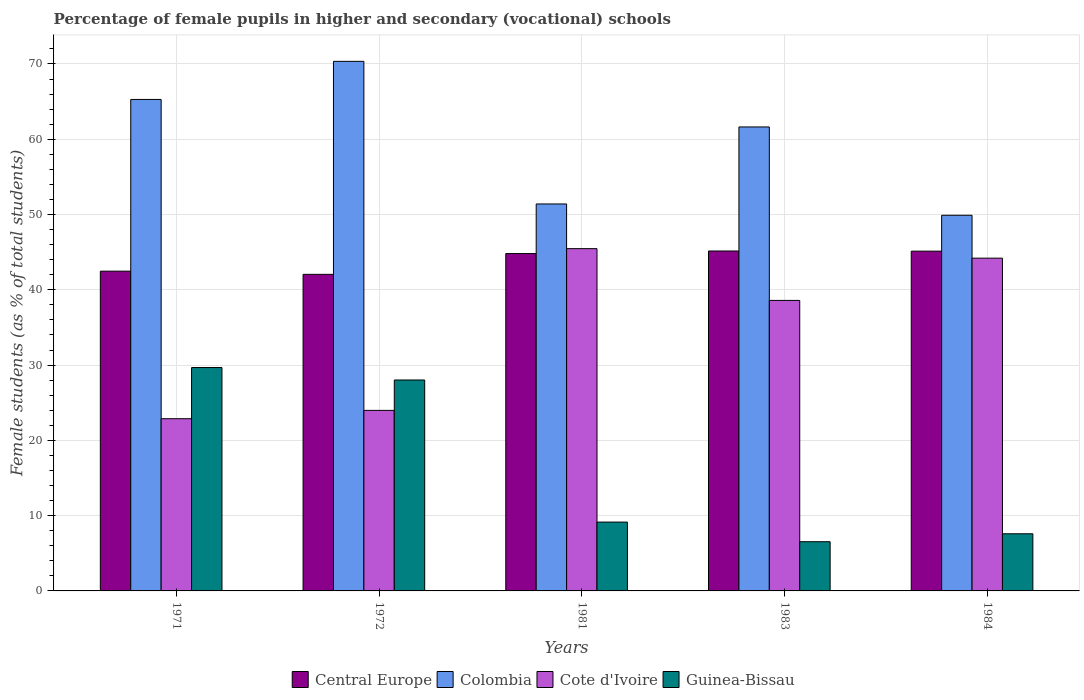How many groups of bars are there?
Your response must be concise. 5. How many bars are there on the 5th tick from the left?
Offer a very short reply. 4. How many bars are there on the 3rd tick from the right?
Offer a terse response. 4. In how many cases, is the number of bars for a given year not equal to the number of legend labels?
Provide a short and direct response. 0. What is the percentage of female pupils in higher and secondary schools in Guinea-Bissau in 1983?
Ensure brevity in your answer.  6.54. Across all years, what is the maximum percentage of female pupils in higher and secondary schools in Guinea-Bissau?
Give a very brief answer. 29.67. Across all years, what is the minimum percentage of female pupils in higher and secondary schools in Cote d'Ivoire?
Keep it short and to the point. 22.88. In which year was the percentage of female pupils in higher and secondary schools in Guinea-Bissau maximum?
Offer a very short reply. 1971. What is the total percentage of female pupils in higher and secondary schools in Central Europe in the graph?
Give a very brief answer. 219.63. What is the difference between the percentage of female pupils in higher and secondary schools in Colombia in 1971 and that in 1984?
Make the answer very short. 15.38. What is the difference between the percentage of female pupils in higher and secondary schools in Central Europe in 1983 and the percentage of female pupils in higher and secondary schools in Cote d'Ivoire in 1984?
Your answer should be very brief. 0.95. What is the average percentage of female pupils in higher and secondary schools in Cote d'Ivoire per year?
Your answer should be very brief. 35.02. In the year 1981, what is the difference between the percentage of female pupils in higher and secondary schools in Cote d'Ivoire and percentage of female pupils in higher and secondary schools in Central Europe?
Make the answer very short. 0.65. What is the ratio of the percentage of female pupils in higher and secondary schools in Guinea-Bissau in 1971 to that in 1972?
Offer a terse response. 1.06. Is the percentage of female pupils in higher and secondary schools in Central Europe in 1971 less than that in 1984?
Provide a short and direct response. Yes. What is the difference between the highest and the second highest percentage of female pupils in higher and secondary schools in Central Europe?
Your answer should be very brief. 0.02. What is the difference between the highest and the lowest percentage of female pupils in higher and secondary schools in Guinea-Bissau?
Provide a succinct answer. 23.14. Is it the case that in every year, the sum of the percentage of female pupils in higher and secondary schools in Cote d'Ivoire and percentage of female pupils in higher and secondary schools in Colombia is greater than the sum of percentage of female pupils in higher and secondary schools in Guinea-Bissau and percentage of female pupils in higher and secondary schools in Central Europe?
Your answer should be very brief. Yes. What does the 2nd bar from the left in 1972 represents?
Give a very brief answer. Colombia. What does the 2nd bar from the right in 1981 represents?
Your answer should be compact. Cote d'Ivoire. Is it the case that in every year, the sum of the percentage of female pupils in higher and secondary schools in Central Europe and percentage of female pupils in higher and secondary schools in Cote d'Ivoire is greater than the percentage of female pupils in higher and secondary schools in Colombia?
Your answer should be compact. No. Does the graph contain any zero values?
Offer a very short reply. No. Where does the legend appear in the graph?
Offer a terse response. Bottom center. How are the legend labels stacked?
Offer a very short reply. Horizontal. What is the title of the graph?
Provide a short and direct response. Percentage of female pupils in higher and secondary (vocational) schools. What is the label or title of the X-axis?
Offer a terse response. Years. What is the label or title of the Y-axis?
Keep it short and to the point. Female students (as % of total students). What is the Female students (as % of total students) in Central Europe in 1971?
Provide a succinct answer. 42.48. What is the Female students (as % of total students) of Colombia in 1971?
Keep it short and to the point. 65.28. What is the Female students (as % of total students) in Cote d'Ivoire in 1971?
Ensure brevity in your answer.  22.88. What is the Female students (as % of total students) of Guinea-Bissau in 1971?
Provide a short and direct response. 29.67. What is the Female students (as % of total students) of Central Europe in 1972?
Provide a short and direct response. 42.05. What is the Female students (as % of total students) of Colombia in 1972?
Offer a terse response. 70.34. What is the Female students (as % of total students) in Cote d'Ivoire in 1972?
Offer a very short reply. 23.98. What is the Female students (as % of total students) of Guinea-Bissau in 1972?
Give a very brief answer. 28.02. What is the Female students (as % of total students) of Central Europe in 1981?
Give a very brief answer. 44.81. What is the Female students (as % of total students) of Colombia in 1981?
Your answer should be compact. 51.4. What is the Female students (as % of total students) of Cote d'Ivoire in 1981?
Ensure brevity in your answer.  45.47. What is the Female students (as % of total students) in Guinea-Bissau in 1981?
Make the answer very short. 9.14. What is the Female students (as % of total students) in Central Europe in 1983?
Give a very brief answer. 45.15. What is the Female students (as % of total students) of Colombia in 1983?
Your answer should be very brief. 61.63. What is the Female students (as % of total students) in Cote d'Ivoire in 1983?
Make the answer very short. 38.59. What is the Female students (as % of total students) in Guinea-Bissau in 1983?
Provide a succinct answer. 6.54. What is the Female students (as % of total students) in Central Europe in 1984?
Offer a terse response. 45.13. What is the Female students (as % of total students) in Colombia in 1984?
Your response must be concise. 49.9. What is the Female students (as % of total students) in Cote d'Ivoire in 1984?
Offer a very short reply. 44.2. What is the Female students (as % of total students) of Guinea-Bissau in 1984?
Your answer should be compact. 7.59. Across all years, what is the maximum Female students (as % of total students) in Central Europe?
Your answer should be compact. 45.15. Across all years, what is the maximum Female students (as % of total students) of Colombia?
Your answer should be very brief. 70.34. Across all years, what is the maximum Female students (as % of total students) of Cote d'Ivoire?
Make the answer very short. 45.47. Across all years, what is the maximum Female students (as % of total students) of Guinea-Bissau?
Ensure brevity in your answer.  29.67. Across all years, what is the minimum Female students (as % of total students) of Central Europe?
Offer a very short reply. 42.05. Across all years, what is the minimum Female students (as % of total students) in Colombia?
Ensure brevity in your answer.  49.9. Across all years, what is the minimum Female students (as % of total students) of Cote d'Ivoire?
Ensure brevity in your answer.  22.88. Across all years, what is the minimum Female students (as % of total students) of Guinea-Bissau?
Your answer should be very brief. 6.54. What is the total Female students (as % of total students) in Central Europe in the graph?
Ensure brevity in your answer.  219.63. What is the total Female students (as % of total students) in Colombia in the graph?
Your answer should be very brief. 298.56. What is the total Female students (as % of total students) in Cote d'Ivoire in the graph?
Ensure brevity in your answer.  175.11. What is the total Female students (as % of total students) in Guinea-Bissau in the graph?
Your response must be concise. 80.96. What is the difference between the Female students (as % of total students) in Central Europe in 1971 and that in 1972?
Provide a short and direct response. 0.43. What is the difference between the Female students (as % of total students) of Colombia in 1971 and that in 1972?
Offer a terse response. -5.06. What is the difference between the Female students (as % of total students) in Cote d'Ivoire in 1971 and that in 1972?
Make the answer very short. -1.11. What is the difference between the Female students (as % of total students) in Guinea-Bissau in 1971 and that in 1972?
Keep it short and to the point. 1.65. What is the difference between the Female students (as % of total students) in Central Europe in 1971 and that in 1981?
Provide a succinct answer. -2.34. What is the difference between the Female students (as % of total students) of Colombia in 1971 and that in 1981?
Offer a very short reply. 13.88. What is the difference between the Female students (as % of total students) of Cote d'Ivoire in 1971 and that in 1981?
Offer a terse response. -22.59. What is the difference between the Female students (as % of total students) of Guinea-Bissau in 1971 and that in 1981?
Offer a very short reply. 20.53. What is the difference between the Female students (as % of total students) of Central Europe in 1971 and that in 1983?
Provide a succinct answer. -2.68. What is the difference between the Female students (as % of total students) in Colombia in 1971 and that in 1983?
Make the answer very short. 3.65. What is the difference between the Female students (as % of total students) of Cote d'Ivoire in 1971 and that in 1983?
Provide a short and direct response. -15.71. What is the difference between the Female students (as % of total students) in Guinea-Bissau in 1971 and that in 1983?
Make the answer very short. 23.14. What is the difference between the Female students (as % of total students) of Central Europe in 1971 and that in 1984?
Provide a succinct answer. -2.66. What is the difference between the Female students (as % of total students) of Colombia in 1971 and that in 1984?
Provide a succinct answer. 15.38. What is the difference between the Female students (as % of total students) in Cote d'Ivoire in 1971 and that in 1984?
Make the answer very short. -21.32. What is the difference between the Female students (as % of total students) of Guinea-Bissau in 1971 and that in 1984?
Make the answer very short. 22.08. What is the difference between the Female students (as % of total students) in Central Europe in 1972 and that in 1981?
Keep it short and to the point. -2.76. What is the difference between the Female students (as % of total students) in Colombia in 1972 and that in 1981?
Provide a short and direct response. 18.94. What is the difference between the Female students (as % of total students) of Cote d'Ivoire in 1972 and that in 1981?
Ensure brevity in your answer.  -21.48. What is the difference between the Female students (as % of total students) in Guinea-Bissau in 1972 and that in 1981?
Ensure brevity in your answer.  18.88. What is the difference between the Female students (as % of total students) of Central Europe in 1972 and that in 1983?
Offer a terse response. -3.1. What is the difference between the Female students (as % of total students) in Colombia in 1972 and that in 1983?
Ensure brevity in your answer.  8.71. What is the difference between the Female students (as % of total students) of Cote d'Ivoire in 1972 and that in 1983?
Your answer should be compact. -14.61. What is the difference between the Female students (as % of total students) in Guinea-Bissau in 1972 and that in 1983?
Keep it short and to the point. 21.48. What is the difference between the Female students (as % of total students) of Central Europe in 1972 and that in 1984?
Offer a very short reply. -3.08. What is the difference between the Female students (as % of total students) in Colombia in 1972 and that in 1984?
Ensure brevity in your answer.  20.44. What is the difference between the Female students (as % of total students) in Cote d'Ivoire in 1972 and that in 1984?
Give a very brief answer. -20.22. What is the difference between the Female students (as % of total students) of Guinea-Bissau in 1972 and that in 1984?
Your answer should be very brief. 20.43. What is the difference between the Female students (as % of total students) in Central Europe in 1981 and that in 1983?
Offer a very short reply. -0.34. What is the difference between the Female students (as % of total students) in Colombia in 1981 and that in 1983?
Provide a short and direct response. -10.23. What is the difference between the Female students (as % of total students) in Cote d'Ivoire in 1981 and that in 1983?
Make the answer very short. 6.88. What is the difference between the Female students (as % of total students) of Guinea-Bissau in 1981 and that in 1983?
Offer a terse response. 2.61. What is the difference between the Female students (as % of total students) of Central Europe in 1981 and that in 1984?
Ensure brevity in your answer.  -0.32. What is the difference between the Female students (as % of total students) of Colombia in 1981 and that in 1984?
Your answer should be compact. 1.5. What is the difference between the Female students (as % of total students) in Cote d'Ivoire in 1981 and that in 1984?
Your answer should be very brief. 1.26. What is the difference between the Female students (as % of total students) of Guinea-Bissau in 1981 and that in 1984?
Your answer should be compact. 1.55. What is the difference between the Female students (as % of total students) of Central Europe in 1983 and that in 1984?
Your answer should be very brief. 0.02. What is the difference between the Female students (as % of total students) in Colombia in 1983 and that in 1984?
Your response must be concise. 11.73. What is the difference between the Female students (as % of total students) of Cote d'Ivoire in 1983 and that in 1984?
Your answer should be compact. -5.61. What is the difference between the Female students (as % of total students) in Guinea-Bissau in 1983 and that in 1984?
Ensure brevity in your answer.  -1.05. What is the difference between the Female students (as % of total students) of Central Europe in 1971 and the Female students (as % of total students) of Colombia in 1972?
Keep it short and to the point. -27.87. What is the difference between the Female students (as % of total students) of Central Europe in 1971 and the Female students (as % of total students) of Cote d'Ivoire in 1972?
Make the answer very short. 18.49. What is the difference between the Female students (as % of total students) in Central Europe in 1971 and the Female students (as % of total students) in Guinea-Bissau in 1972?
Give a very brief answer. 14.46. What is the difference between the Female students (as % of total students) of Colombia in 1971 and the Female students (as % of total students) of Cote d'Ivoire in 1972?
Offer a terse response. 41.3. What is the difference between the Female students (as % of total students) in Colombia in 1971 and the Female students (as % of total students) in Guinea-Bissau in 1972?
Your response must be concise. 37.26. What is the difference between the Female students (as % of total students) of Cote d'Ivoire in 1971 and the Female students (as % of total students) of Guinea-Bissau in 1972?
Your response must be concise. -5.14. What is the difference between the Female students (as % of total students) of Central Europe in 1971 and the Female students (as % of total students) of Colombia in 1981?
Provide a short and direct response. -8.92. What is the difference between the Female students (as % of total students) in Central Europe in 1971 and the Female students (as % of total students) in Cote d'Ivoire in 1981?
Provide a succinct answer. -2.99. What is the difference between the Female students (as % of total students) in Central Europe in 1971 and the Female students (as % of total students) in Guinea-Bissau in 1981?
Give a very brief answer. 33.33. What is the difference between the Female students (as % of total students) of Colombia in 1971 and the Female students (as % of total students) of Cote d'Ivoire in 1981?
Your answer should be very brief. 19.82. What is the difference between the Female students (as % of total students) of Colombia in 1971 and the Female students (as % of total students) of Guinea-Bissau in 1981?
Keep it short and to the point. 56.14. What is the difference between the Female students (as % of total students) in Cote d'Ivoire in 1971 and the Female students (as % of total students) in Guinea-Bissau in 1981?
Ensure brevity in your answer.  13.73. What is the difference between the Female students (as % of total students) of Central Europe in 1971 and the Female students (as % of total students) of Colombia in 1983?
Your answer should be compact. -19.15. What is the difference between the Female students (as % of total students) in Central Europe in 1971 and the Female students (as % of total students) in Cote d'Ivoire in 1983?
Your answer should be very brief. 3.89. What is the difference between the Female students (as % of total students) of Central Europe in 1971 and the Female students (as % of total students) of Guinea-Bissau in 1983?
Provide a short and direct response. 35.94. What is the difference between the Female students (as % of total students) in Colombia in 1971 and the Female students (as % of total students) in Cote d'Ivoire in 1983?
Keep it short and to the point. 26.69. What is the difference between the Female students (as % of total students) in Colombia in 1971 and the Female students (as % of total students) in Guinea-Bissau in 1983?
Provide a short and direct response. 58.75. What is the difference between the Female students (as % of total students) in Cote d'Ivoire in 1971 and the Female students (as % of total students) in Guinea-Bissau in 1983?
Your response must be concise. 16.34. What is the difference between the Female students (as % of total students) in Central Europe in 1971 and the Female students (as % of total students) in Colombia in 1984?
Offer a very short reply. -7.42. What is the difference between the Female students (as % of total students) in Central Europe in 1971 and the Female students (as % of total students) in Cote d'Ivoire in 1984?
Offer a very short reply. -1.72. What is the difference between the Female students (as % of total students) of Central Europe in 1971 and the Female students (as % of total students) of Guinea-Bissau in 1984?
Ensure brevity in your answer.  34.89. What is the difference between the Female students (as % of total students) of Colombia in 1971 and the Female students (as % of total students) of Cote d'Ivoire in 1984?
Provide a succinct answer. 21.08. What is the difference between the Female students (as % of total students) in Colombia in 1971 and the Female students (as % of total students) in Guinea-Bissau in 1984?
Your response must be concise. 57.69. What is the difference between the Female students (as % of total students) of Cote d'Ivoire in 1971 and the Female students (as % of total students) of Guinea-Bissau in 1984?
Your answer should be very brief. 15.29. What is the difference between the Female students (as % of total students) in Central Europe in 1972 and the Female students (as % of total students) in Colombia in 1981?
Provide a succinct answer. -9.35. What is the difference between the Female students (as % of total students) of Central Europe in 1972 and the Female students (as % of total students) of Cote d'Ivoire in 1981?
Your answer should be very brief. -3.42. What is the difference between the Female students (as % of total students) of Central Europe in 1972 and the Female students (as % of total students) of Guinea-Bissau in 1981?
Offer a very short reply. 32.91. What is the difference between the Female students (as % of total students) of Colombia in 1972 and the Female students (as % of total students) of Cote d'Ivoire in 1981?
Give a very brief answer. 24.88. What is the difference between the Female students (as % of total students) in Colombia in 1972 and the Female students (as % of total students) in Guinea-Bissau in 1981?
Ensure brevity in your answer.  61.2. What is the difference between the Female students (as % of total students) in Cote d'Ivoire in 1972 and the Female students (as % of total students) in Guinea-Bissau in 1981?
Keep it short and to the point. 14.84. What is the difference between the Female students (as % of total students) in Central Europe in 1972 and the Female students (as % of total students) in Colombia in 1983?
Your response must be concise. -19.58. What is the difference between the Female students (as % of total students) of Central Europe in 1972 and the Female students (as % of total students) of Cote d'Ivoire in 1983?
Ensure brevity in your answer.  3.46. What is the difference between the Female students (as % of total students) in Central Europe in 1972 and the Female students (as % of total students) in Guinea-Bissau in 1983?
Offer a terse response. 35.51. What is the difference between the Female students (as % of total students) in Colombia in 1972 and the Female students (as % of total students) in Cote d'Ivoire in 1983?
Keep it short and to the point. 31.75. What is the difference between the Female students (as % of total students) in Colombia in 1972 and the Female students (as % of total students) in Guinea-Bissau in 1983?
Offer a very short reply. 63.81. What is the difference between the Female students (as % of total students) of Cote d'Ivoire in 1972 and the Female students (as % of total students) of Guinea-Bissau in 1983?
Your answer should be compact. 17.45. What is the difference between the Female students (as % of total students) in Central Europe in 1972 and the Female students (as % of total students) in Colombia in 1984?
Provide a short and direct response. -7.85. What is the difference between the Female students (as % of total students) in Central Europe in 1972 and the Female students (as % of total students) in Cote d'Ivoire in 1984?
Offer a terse response. -2.15. What is the difference between the Female students (as % of total students) in Central Europe in 1972 and the Female students (as % of total students) in Guinea-Bissau in 1984?
Your response must be concise. 34.46. What is the difference between the Female students (as % of total students) in Colombia in 1972 and the Female students (as % of total students) in Cote d'Ivoire in 1984?
Your answer should be very brief. 26.14. What is the difference between the Female students (as % of total students) in Colombia in 1972 and the Female students (as % of total students) in Guinea-Bissau in 1984?
Provide a short and direct response. 62.75. What is the difference between the Female students (as % of total students) in Cote d'Ivoire in 1972 and the Female students (as % of total students) in Guinea-Bissau in 1984?
Offer a very short reply. 16.39. What is the difference between the Female students (as % of total students) of Central Europe in 1981 and the Female students (as % of total students) of Colombia in 1983?
Make the answer very short. -16.82. What is the difference between the Female students (as % of total students) of Central Europe in 1981 and the Female students (as % of total students) of Cote d'Ivoire in 1983?
Your response must be concise. 6.22. What is the difference between the Female students (as % of total students) of Central Europe in 1981 and the Female students (as % of total students) of Guinea-Bissau in 1983?
Ensure brevity in your answer.  38.28. What is the difference between the Female students (as % of total students) in Colombia in 1981 and the Female students (as % of total students) in Cote d'Ivoire in 1983?
Your answer should be compact. 12.81. What is the difference between the Female students (as % of total students) in Colombia in 1981 and the Female students (as % of total students) in Guinea-Bissau in 1983?
Make the answer very short. 44.87. What is the difference between the Female students (as % of total students) of Cote d'Ivoire in 1981 and the Female students (as % of total students) of Guinea-Bissau in 1983?
Provide a succinct answer. 38.93. What is the difference between the Female students (as % of total students) in Central Europe in 1981 and the Female students (as % of total students) in Colombia in 1984?
Offer a very short reply. -5.09. What is the difference between the Female students (as % of total students) in Central Europe in 1981 and the Female students (as % of total students) in Cote d'Ivoire in 1984?
Ensure brevity in your answer.  0.61. What is the difference between the Female students (as % of total students) of Central Europe in 1981 and the Female students (as % of total students) of Guinea-Bissau in 1984?
Keep it short and to the point. 37.22. What is the difference between the Female students (as % of total students) in Colombia in 1981 and the Female students (as % of total students) in Cote d'Ivoire in 1984?
Provide a succinct answer. 7.2. What is the difference between the Female students (as % of total students) in Colombia in 1981 and the Female students (as % of total students) in Guinea-Bissau in 1984?
Offer a very short reply. 43.81. What is the difference between the Female students (as % of total students) in Cote d'Ivoire in 1981 and the Female students (as % of total students) in Guinea-Bissau in 1984?
Your answer should be compact. 37.87. What is the difference between the Female students (as % of total students) in Central Europe in 1983 and the Female students (as % of total students) in Colombia in 1984?
Offer a very short reply. -4.75. What is the difference between the Female students (as % of total students) in Central Europe in 1983 and the Female students (as % of total students) in Cote d'Ivoire in 1984?
Your answer should be compact. 0.95. What is the difference between the Female students (as % of total students) of Central Europe in 1983 and the Female students (as % of total students) of Guinea-Bissau in 1984?
Your answer should be very brief. 37.56. What is the difference between the Female students (as % of total students) of Colombia in 1983 and the Female students (as % of total students) of Cote d'Ivoire in 1984?
Keep it short and to the point. 17.43. What is the difference between the Female students (as % of total students) of Colombia in 1983 and the Female students (as % of total students) of Guinea-Bissau in 1984?
Provide a succinct answer. 54.04. What is the difference between the Female students (as % of total students) in Cote d'Ivoire in 1983 and the Female students (as % of total students) in Guinea-Bissau in 1984?
Offer a very short reply. 31. What is the average Female students (as % of total students) of Central Europe per year?
Make the answer very short. 43.93. What is the average Female students (as % of total students) in Colombia per year?
Provide a succinct answer. 59.71. What is the average Female students (as % of total students) in Cote d'Ivoire per year?
Make the answer very short. 35.02. What is the average Female students (as % of total students) in Guinea-Bissau per year?
Keep it short and to the point. 16.19. In the year 1971, what is the difference between the Female students (as % of total students) of Central Europe and Female students (as % of total students) of Colombia?
Provide a short and direct response. -22.81. In the year 1971, what is the difference between the Female students (as % of total students) in Central Europe and Female students (as % of total students) in Cote d'Ivoire?
Ensure brevity in your answer.  19.6. In the year 1971, what is the difference between the Female students (as % of total students) of Central Europe and Female students (as % of total students) of Guinea-Bissau?
Keep it short and to the point. 12.8. In the year 1971, what is the difference between the Female students (as % of total students) of Colombia and Female students (as % of total students) of Cote d'Ivoire?
Give a very brief answer. 42.41. In the year 1971, what is the difference between the Female students (as % of total students) of Colombia and Female students (as % of total students) of Guinea-Bissau?
Give a very brief answer. 35.61. In the year 1971, what is the difference between the Female students (as % of total students) of Cote d'Ivoire and Female students (as % of total students) of Guinea-Bissau?
Provide a succinct answer. -6.8. In the year 1972, what is the difference between the Female students (as % of total students) in Central Europe and Female students (as % of total students) in Colombia?
Your answer should be very brief. -28.29. In the year 1972, what is the difference between the Female students (as % of total students) of Central Europe and Female students (as % of total students) of Cote d'Ivoire?
Give a very brief answer. 18.07. In the year 1972, what is the difference between the Female students (as % of total students) of Central Europe and Female students (as % of total students) of Guinea-Bissau?
Your answer should be compact. 14.03. In the year 1972, what is the difference between the Female students (as % of total students) of Colombia and Female students (as % of total students) of Cote d'Ivoire?
Your answer should be compact. 46.36. In the year 1972, what is the difference between the Female students (as % of total students) in Colombia and Female students (as % of total students) in Guinea-Bissau?
Keep it short and to the point. 42.33. In the year 1972, what is the difference between the Female students (as % of total students) in Cote d'Ivoire and Female students (as % of total students) in Guinea-Bissau?
Give a very brief answer. -4.04. In the year 1981, what is the difference between the Female students (as % of total students) of Central Europe and Female students (as % of total students) of Colombia?
Offer a terse response. -6.59. In the year 1981, what is the difference between the Female students (as % of total students) of Central Europe and Female students (as % of total students) of Cote d'Ivoire?
Ensure brevity in your answer.  -0.65. In the year 1981, what is the difference between the Female students (as % of total students) of Central Europe and Female students (as % of total students) of Guinea-Bissau?
Keep it short and to the point. 35.67. In the year 1981, what is the difference between the Female students (as % of total students) in Colombia and Female students (as % of total students) in Cote d'Ivoire?
Provide a succinct answer. 5.94. In the year 1981, what is the difference between the Female students (as % of total students) in Colombia and Female students (as % of total students) in Guinea-Bissau?
Make the answer very short. 42.26. In the year 1981, what is the difference between the Female students (as % of total students) in Cote d'Ivoire and Female students (as % of total students) in Guinea-Bissau?
Give a very brief answer. 36.32. In the year 1983, what is the difference between the Female students (as % of total students) of Central Europe and Female students (as % of total students) of Colombia?
Provide a short and direct response. -16.48. In the year 1983, what is the difference between the Female students (as % of total students) of Central Europe and Female students (as % of total students) of Cote d'Ivoire?
Your response must be concise. 6.56. In the year 1983, what is the difference between the Female students (as % of total students) in Central Europe and Female students (as % of total students) in Guinea-Bissau?
Keep it short and to the point. 38.62. In the year 1983, what is the difference between the Female students (as % of total students) of Colombia and Female students (as % of total students) of Cote d'Ivoire?
Make the answer very short. 23.04. In the year 1983, what is the difference between the Female students (as % of total students) of Colombia and Female students (as % of total students) of Guinea-Bissau?
Offer a very short reply. 55.1. In the year 1983, what is the difference between the Female students (as % of total students) in Cote d'Ivoire and Female students (as % of total students) in Guinea-Bissau?
Provide a short and direct response. 32.05. In the year 1984, what is the difference between the Female students (as % of total students) in Central Europe and Female students (as % of total students) in Colombia?
Give a very brief answer. -4.77. In the year 1984, what is the difference between the Female students (as % of total students) in Central Europe and Female students (as % of total students) in Cote d'Ivoire?
Keep it short and to the point. 0.93. In the year 1984, what is the difference between the Female students (as % of total students) of Central Europe and Female students (as % of total students) of Guinea-Bissau?
Offer a terse response. 37.54. In the year 1984, what is the difference between the Female students (as % of total students) in Colombia and Female students (as % of total students) in Cote d'Ivoire?
Keep it short and to the point. 5.7. In the year 1984, what is the difference between the Female students (as % of total students) of Colombia and Female students (as % of total students) of Guinea-Bissau?
Offer a very short reply. 42.31. In the year 1984, what is the difference between the Female students (as % of total students) in Cote d'Ivoire and Female students (as % of total students) in Guinea-Bissau?
Offer a terse response. 36.61. What is the ratio of the Female students (as % of total students) in Central Europe in 1971 to that in 1972?
Your response must be concise. 1.01. What is the ratio of the Female students (as % of total students) in Colombia in 1971 to that in 1972?
Make the answer very short. 0.93. What is the ratio of the Female students (as % of total students) of Cote d'Ivoire in 1971 to that in 1972?
Make the answer very short. 0.95. What is the ratio of the Female students (as % of total students) in Guinea-Bissau in 1971 to that in 1972?
Offer a terse response. 1.06. What is the ratio of the Female students (as % of total students) in Central Europe in 1971 to that in 1981?
Provide a short and direct response. 0.95. What is the ratio of the Female students (as % of total students) of Colombia in 1971 to that in 1981?
Give a very brief answer. 1.27. What is the ratio of the Female students (as % of total students) in Cote d'Ivoire in 1971 to that in 1981?
Your answer should be compact. 0.5. What is the ratio of the Female students (as % of total students) of Guinea-Bissau in 1971 to that in 1981?
Your response must be concise. 3.25. What is the ratio of the Female students (as % of total students) of Central Europe in 1971 to that in 1983?
Provide a succinct answer. 0.94. What is the ratio of the Female students (as % of total students) in Colombia in 1971 to that in 1983?
Your response must be concise. 1.06. What is the ratio of the Female students (as % of total students) of Cote d'Ivoire in 1971 to that in 1983?
Keep it short and to the point. 0.59. What is the ratio of the Female students (as % of total students) of Guinea-Bissau in 1971 to that in 1983?
Keep it short and to the point. 4.54. What is the ratio of the Female students (as % of total students) in Central Europe in 1971 to that in 1984?
Offer a terse response. 0.94. What is the ratio of the Female students (as % of total students) in Colombia in 1971 to that in 1984?
Offer a terse response. 1.31. What is the ratio of the Female students (as % of total students) in Cote d'Ivoire in 1971 to that in 1984?
Your response must be concise. 0.52. What is the ratio of the Female students (as % of total students) of Guinea-Bissau in 1971 to that in 1984?
Provide a succinct answer. 3.91. What is the ratio of the Female students (as % of total students) of Central Europe in 1972 to that in 1981?
Ensure brevity in your answer.  0.94. What is the ratio of the Female students (as % of total students) in Colombia in 1972 to that in 1981?
Give a very brief answer. 1.37. What is the ratio of the Female students (as % of total students) in Cote d'Ivoire in 1972 to that in 1981?
Provide a succinct answer. 0.53. What is the ratio of the Female students (as % of total students) in Guinea-Bissau in 1972 to that in 1981?
Give a very brief answer. 3.06. What is the ratio of the Female students (as % of total students) of Central Europe in 1972 to that in 1983?
Your response must be concise. 0.93. What is the ratio of the Female students (as % of total students) of Colombia in 1972 to that in 1983?
Your answer should be compact. 1.14. What is the ratio of the Female students (as % of total students) of Cote d'Ivoire in 1972 to that in 1983?
Give a very brief answer. 0.62. What is the ratio of the Female students (as % of total students) of Guinea-Bissau in 1972 to that in 1983?
Make the answer very short. 4.29. What is the ratio of the Female students (as % of total students) of Central Europe in 1972 to that in 1984?
Provide a succinct answer. 0.93. What is the ratio of the Female students (as % of total students) in Colombia in 1972 to that in 1984?
Your answer should be very brief. 1.41. What is the ratio of the Female students (as % of total students) in Cote d'Ivoire in 1972 to that in 1984?
Your answer should be very brief. 0.54. What is the ratio of the Female students (as % of total students) in Guinea-Bissau in 1972 to that in 1984?
Provide a succinct answer. 3.69. What is the ratio of the Female students (as % of total students) of Colombia in 1981 to that in 1983?
Keep it short and to the point. 0.83. What is the ratio of the Female students (as % of total students) of Cote d'Ivoire in 1981 to that in 1983?
Keep it short and to the point. 1.18. What is the ratio of the Female students (as % of total students) in Guinea-Bissau in 1981 to that in 1983?
Make the answer very short. 1.4. What is the ratio of the Female students (as % of total students) in Central Europe in 1981 to that in 1984?
Your response must be concise. 0.99. What is the ratio of the Female students (as % of total students) of Colombia in 1981 to that in 1984?
Ensure brevity in your answer.  1.03. What is the ratio of the Female students (as % of total students) of Cote d'Ivoire in 1981 to that in 1984?
Offer a very short reply. 1.03. What is the ratio of the Female students (as % of total students) in Guinea-Bissau in 1981 to that in 1984?
Offer a very short reply. 1.2. What is the ratio of the Female students (as % of total students) of Central Europe in 1983 to that in 1984?
Provide a short and direct response. 1. What is the ratio of the Female students (as % of total students) in Colombia in 1983 to that in 1984?
Offer a terse response. 1.24. What is the ratio of the Female students (as % of total students) of Cote d'Ivoire in 1983 to that in 1984?
Give a very brief answer. 0.87. What is the ratio of the Female students (as % of total students) of Guinea-Bissau in 1983 to that in 1984?
Make the answer very short. 0.86. What is the difference between the highest and the second highest Female students (as % of total students) in Central Europe?
Provide a short and direct response. 0.02. What is the difference between the highest and the second highest Female students (as % of total students) of Colombia?
Provide a short and direct response. 5.06. What is the difference between the highest and the second highest Female students (as % of total students) of Cote d'Ivoire?
Your answer should be compact. 1.26. What is the difference between the highest and the second highest Female students (as % of total students) of Guinea-Bissau?
Provide a succinct answer. 1.65. What is the difference between the highest and the lowest Female students (as % of total students) in Central Europe?
Keep it short and to the point. 3.1. What is the difference between the highest and the lowest Female students (as % of total students) of Colombia?
Ensure brevity in your answer.  20.44. What is the difference between the highest and the lowest Female students (as % of total students) in Cote d'Ivoire?
Offer a terse response. 22.59. What is the difference between the highest and the lowest Female students (as % of total students) of Guinea-Bissau?
Offer a terse response. 23.14. 